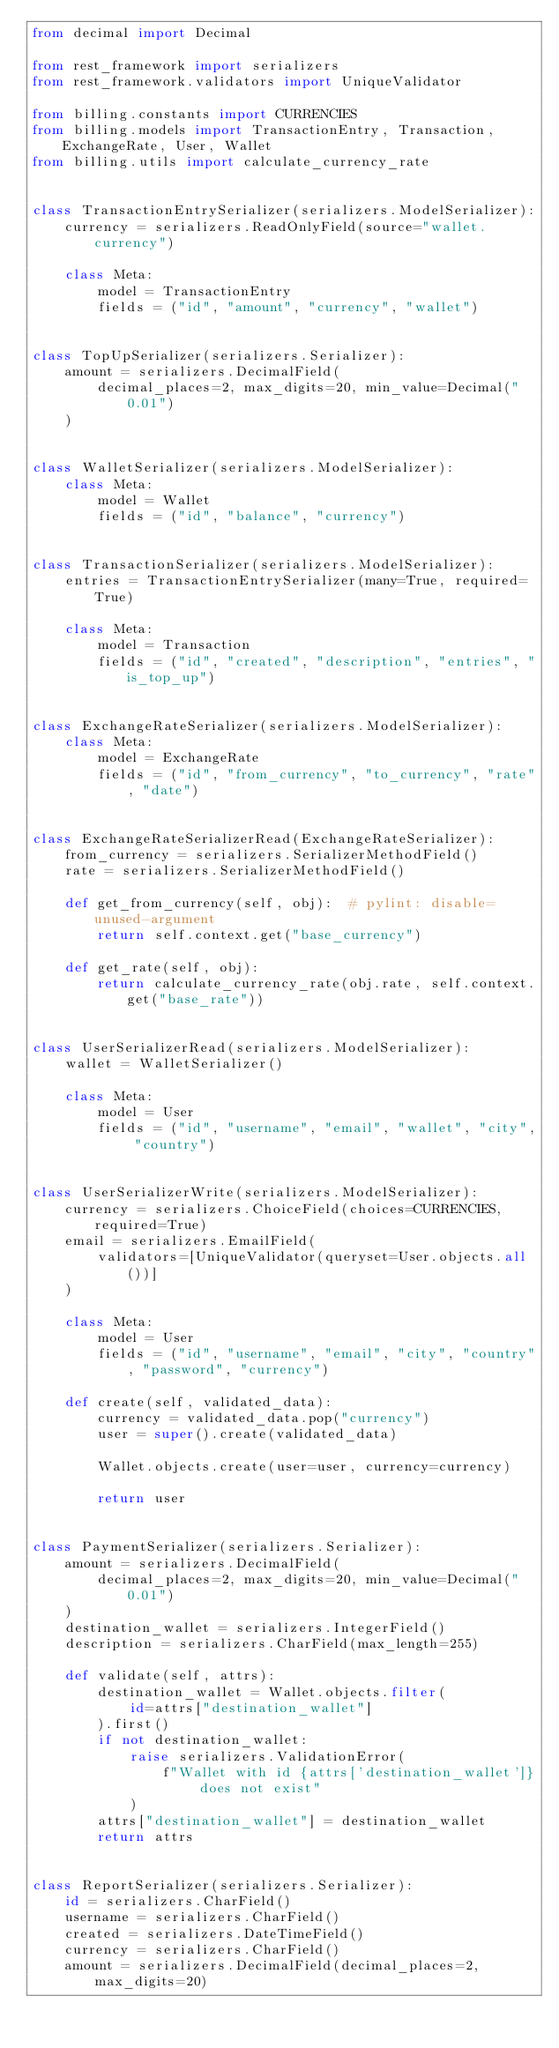Convert code to text. <code><loc_0><loc_0><loc_500><loc_500><_Python_>from decimal import Decimal

from rest_framework import serializers
from rest_framework.validators import UniqueValidator

from billing.constants import CURRENCIES
from billing.models import TransactionEntry, Transaction, ExchangeRate, User, Wallet
from billing.utils import calculate_currency_rate


class TransactionEntrySerializer(serializers.ModelSerializer):
    currency = serializers.ReadOnlyField(source="wallet.currency")

    class Meta:
        model = TransactionEntry
        fields = ("id", "amount", "currency", "wallet")


class TopUpSerializer(serializers.Serializer):
    amount = serializers.DecimalField(
        decimal_places=2, max_digits=20, min_value=Decimal("0.01")
    )


class WalletSerializer(serializers.ModelSerializer):
    class Meta:
        model = Wallet
        fields = ("id", "balance", "currency")


class TransactionSerializer(serializers.ModelSerializer):
    entries = TransactionEntrySerializer(many=True, required=True)

    class Meta:
        model = Transaction
        fields = ("id", "created", "description", "entries", "is_top_up")


class ExchangeRateSerializer(serializers.ModelSerializer):
    class Meta:
        model = ExchangeRate
        fields = ("id", "from_currency", "to_currency", "rate", "date")


class ExchangeRateSerializerRead(ExchangeRateSerializer):
    from_currency = serializers.SerializerMethodField()
    rate = serializers.SerializerMethodField()

    def get_from_currency(self, obj):  # pylint: disable=unused-argument
        return self.context.get("base_currency")

    def get_rate(self, obj):
        return calculate_currency_rate(obj.rate, self.context.get("base_rate"))


class UserSerializerRead(serializers.ModelSerializer):
    wallet = WalletSerializer()

    class Meta:
        model = User
        fields = ("id", "username", "email", "wallet", "city", "country")


class UserSerializerWrite(serializers.ModelSerializer):
    currency = serializers.ChoiceField(choices=CURRENCIES, required=True)
    email = serializers.EmailField(
        validators=[UniqueValidator(queryset=User.objects.all())]
    )

    class Meta:
        model = User
        fields = ("id", "username", "email", "city", "country", "password", "currency")

    def create(self, validated_data):
        currency = validated_data.pop("currency")
        user = super().create(validated_data)

        Wallet.objects.create(user=user, currency=currency)

        return user


class PaymentSerializer(serializers.Serializer):
    amount = serializers.DecimalField(
        decimal_places=2, max_digits=20, min_value=Decimal("0.01")
    )
    destination_wallet = serializers.IntegerField()
    description = serializers.CharField(max_length=255)

    def validate(self, attrs):
        destination_wallet = Wallet.objects.filter(
            id=attrs["destination_wallet"]
        ).first()
        if not destination_wallet:
            raise serializers.ValidationError(
                f"Wallet with id {attrs['destination_wallet']} does not exist"
            )
        attrs["destination_wallet"] = destination_wallet
        return attrs


class ReportSerializer(serializers.Serializer):
    id = serializers.CharField()
    username = serializers.CharField()
    created = serializers.DateTimeField()
    currency = serializers.CharField()
    amount = serializers.DecimalField(decimal_places=2, max_digits=20)
</code> 